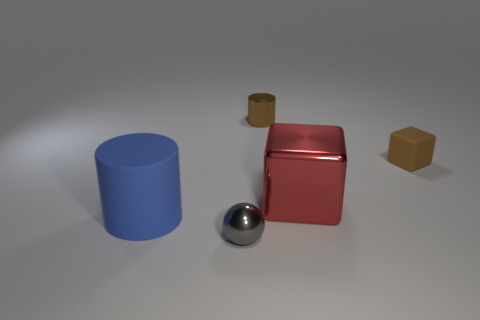What material is the tiny cube that is the same color as the small shiny cylinder? The tiny cube that shares its color with the small shiny cylinder appears to be made of plastic, based on its matte appearance and edges that are typical of molded or cast plastic objects. 